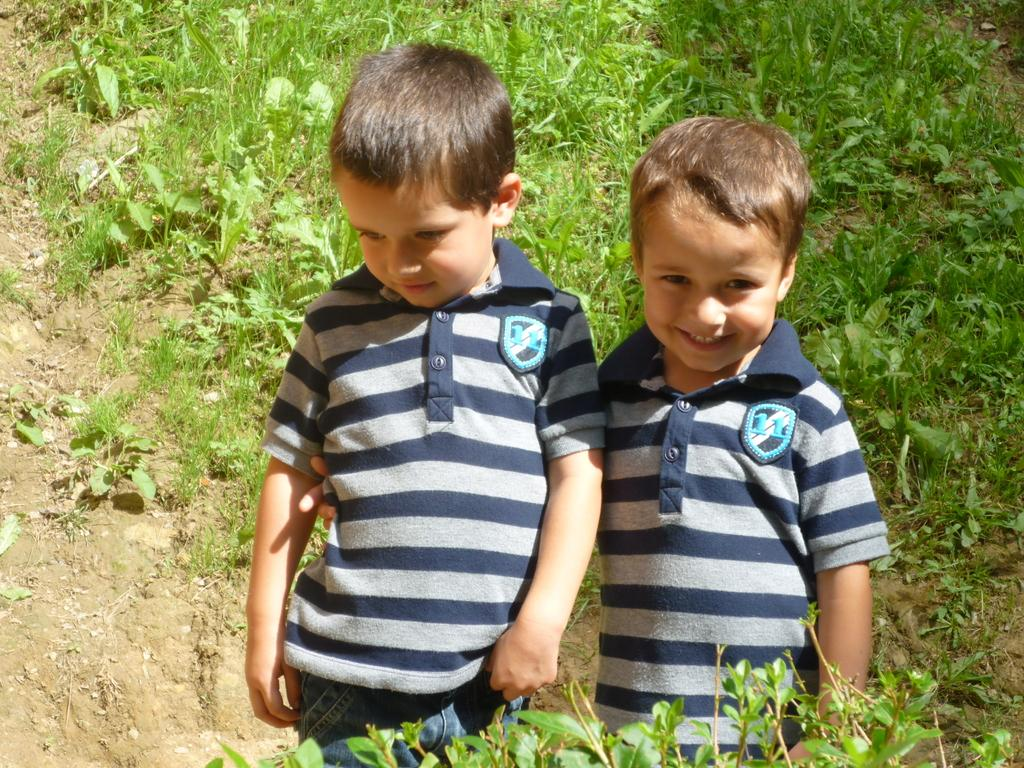How many boys are in the image? There are two boys in the image. What are the boys wearing? The boys are wearing the same dress. What can be seen near the boys in the image? The boys are standing near a plant. What type of vegetation is visible at the top of the image? There is green grass visible at the top of the image. Can you see any ants crawling on the boys' dresses in the image? There are no ants visible in the image, and therefore, none can be seen crawling on the boys' dresses. 